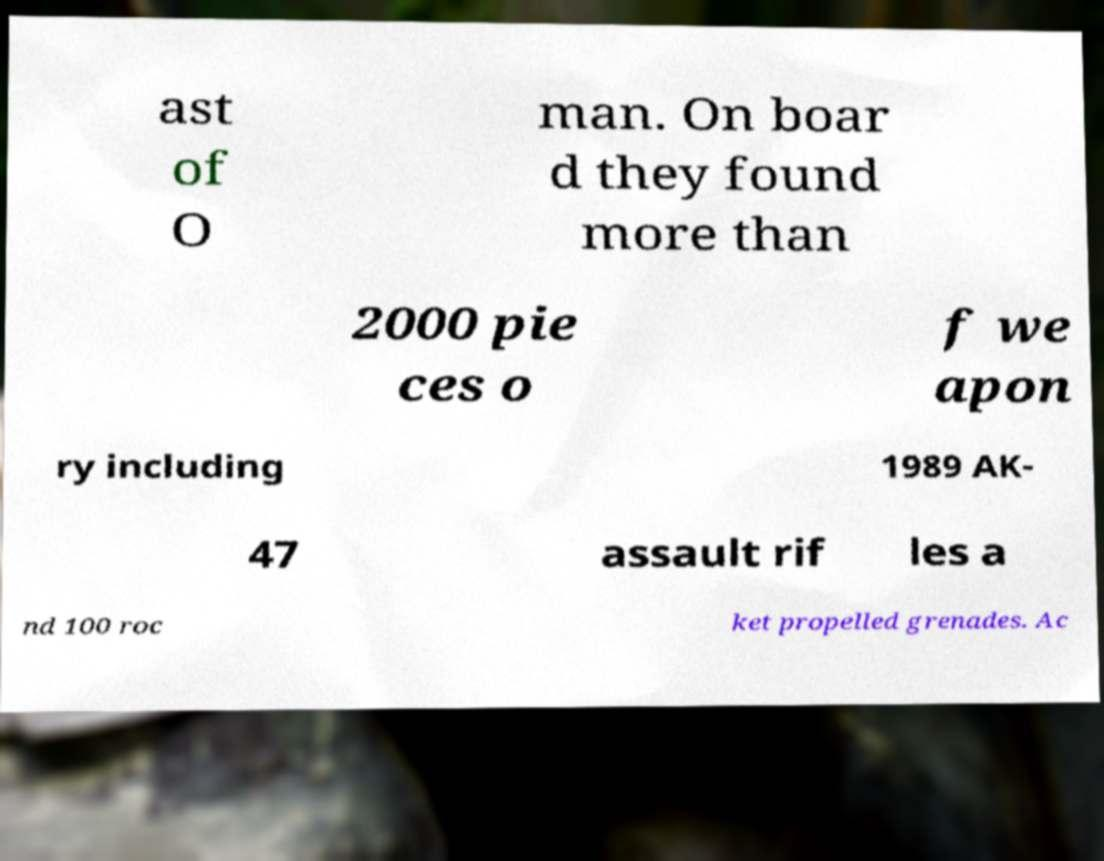What messages or text are displayed in this image? I need them in a readable, typed format. ast of O man. On boar d they found more than 2000 pie ces o f we apon ry including 1989 AK- 47 assault rif les a nd 100 roc ket propelled grenades. Ac 